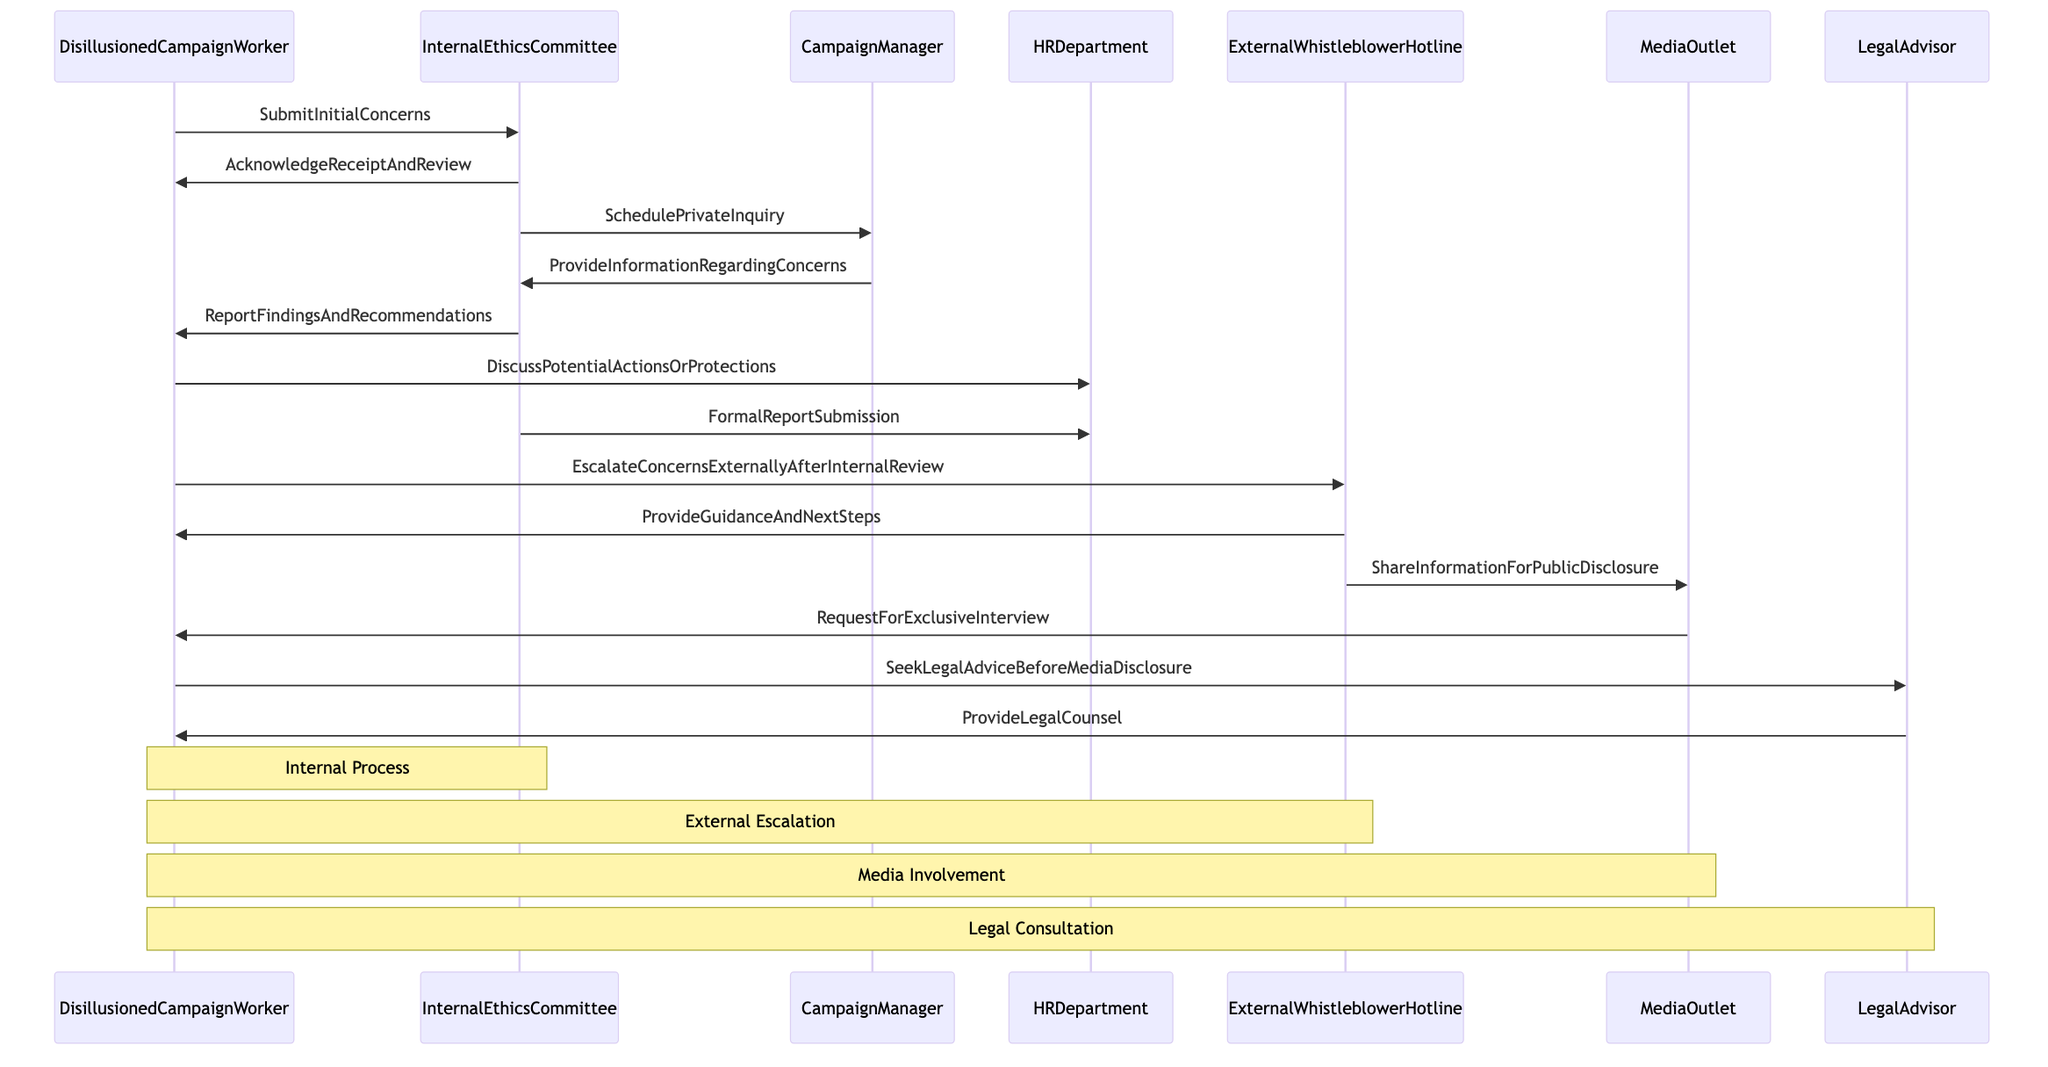What actor submits initial concerns in the process? The diagram indicates that the "DisillusionedCampaignWorker" submits the initial concerns to the "InternalEthicsCommittee."
Answer: DisillusionedCampaignWorker How many interactions occur between the DisillusionedCampaignWorker and the InternalEthicsCommittee? By reviewing the diagram, there are three interactions: the submission of initial concerns, acknowledgment of receipt, and reporting findings and recommendations.
Answer: Three Which actor is responsible for providing legal counsel? The "LegalAdvisor" provides legal counsel in the diagram, as indicated in the interaction flow where the DisillusionedCampaignWorker seeks legal advice before media disclosure.
Answer: LegalAdvisor What is the final action taken by the DisillusionedCampaignWorker in the process? The final action taken by the DisillusionedCampaignWorker is seeking legal advice from the LegalAdvisor, which occurs before any media disclosure.
Answer: SeekLegalAdviceBeforeMediaDisclosure Which two actors are involved in the process of escalating concerns externally? The actors involved in escalating concerns externally are the "DisillusionedCampaignWorker" and the "ExternalWhistleblowerHotline" as shown in the interactions labeled with escalation actions.
Answer: DisillusionedCampaignWorker and ExternalWhistleblowerHotline What does the InternalEthicsCommittee do after receiving the initial concerns? The InternalEthicsCommittee acknowledges receipt and reviews the concerns after receiving the initial submission from the DisillusionedCampaignWorker.
Answer: AcknowledgeReceiptAndReview Which actors are involved in discussing potential actions or protections? The diagram shows that the "DisillusionedCampaignWorker" is involved in discussions with the "HRDepartment" regarding potential actions or protections.
Answer: DisillusionedCampaignWorker and HRDepartment How many actors are involved in the whistleblowing process? A total of seven actors are involved in the whistleblowing process as indicated in the diagram.
Answer: Seven 